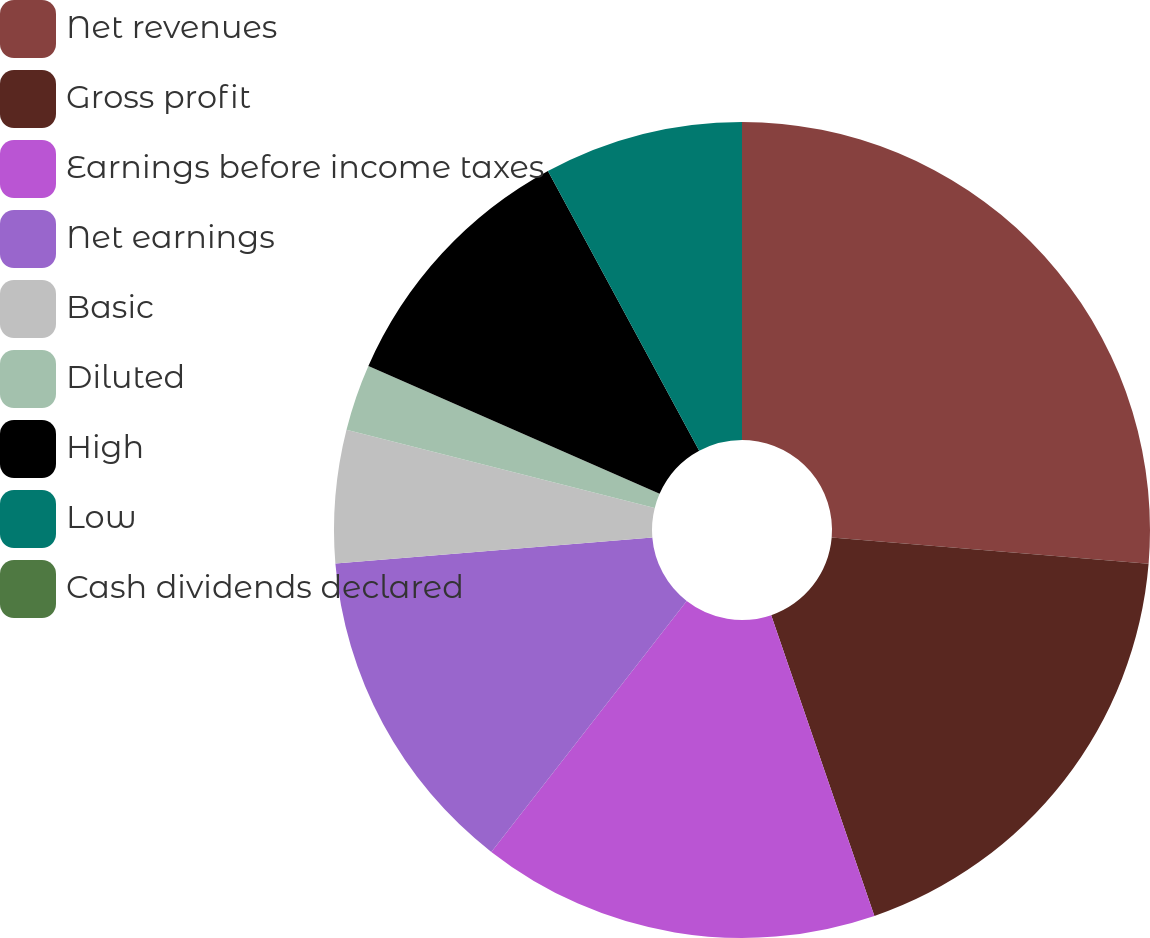<chart> <loc_0><loc_0><loc_500><loc_500><pie_chart><fcel>Net revenues<fcel>Gross profit<fcel>Earnings before income taxes<fcel>Net earnings<fcel>Basic<fcel>Diluted<fcel>High<fcel>Low<fcel>Cash dividends declared<nl><fcel>26.32%<fcel>18.42%<fcel>15.79%<fcel>13.16%<fcel>5.26%<fcel>2.63%<fcel>10.53%<fcel>7.89%<fcel>0.0%<nl></chart> 